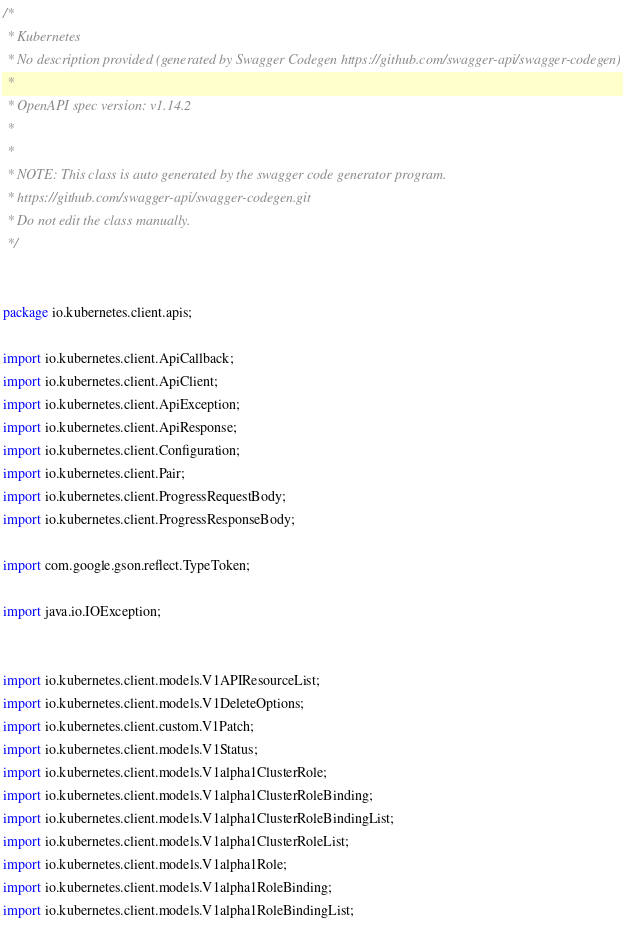<code> <loc_0><loc_0><loc_500><loc_500><_Java_>/*
 * Kubernetes
 * No description provided (generated by Swagger Codegen https://github.com/swagger-api/swagger-codegen)
 *
 * OpenAPI spec version: v1.14.2
 * 
 *
 * NOTE: This class is auto generated by the swagger code generator program.
 * https://github.com/swagger-api/swagger-codegen.git
 * Do not edit the class manually.
 */


package io.kubernetes.client.apis;

import io.kubernetes.client.ApiCallback;
import io.kubernetes.client.ApiClient;
import io.kubernetes.client.ApiException;
import io.kubernetes.client.ApiResponse;
import io.kubernetes.client.Configuration;
import io.kubernetes.client.Pair;
import io.kubernetes.client.ProgressRequestBody;
import io.kubernetes.client.ProgressResponseBody;

import com.google.gson.reflect.TypeToken;

import java.io.IOException;


import io.kubernetes.client.models.V1APIResourceList;
import io.kubernetes.client.models.V1DeleteOptions;
import io.kubernetes.client.custom.V1Patch;
import io.kubernetes.client.models.V1Status;
import io.kubernetes.client.models.V1alpha1ClusterRole;
import io.kubernetes.client.models.V1alpha1ClusterRoleBinding;
import io.kubernetes.client.models.V1alpha1ClusterRoleBindingList;
import io.kubernetes.client.models.V1alpha1ClusterRoleList;
import io.kubernetes.client.models.V1alpha1Role;
import io.kubernetes.client.models.V1alpha1RoleBinding;
import io.kubernetes.client.models.V1alpha1RoleBindingList;</code> 